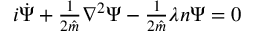Convert formula to latex. <formula><loc_0><loc_0><loc_500><loc_500>\begin{array} { r } { i \dot { \Psi } + \frac { 1 } { 2 \hat { m } } \nabla ^ { 2 } \Psi - \frac { 1 } { 2 \hat { m } } \lambda n \Psi = 0 } \end{array}</formula> 